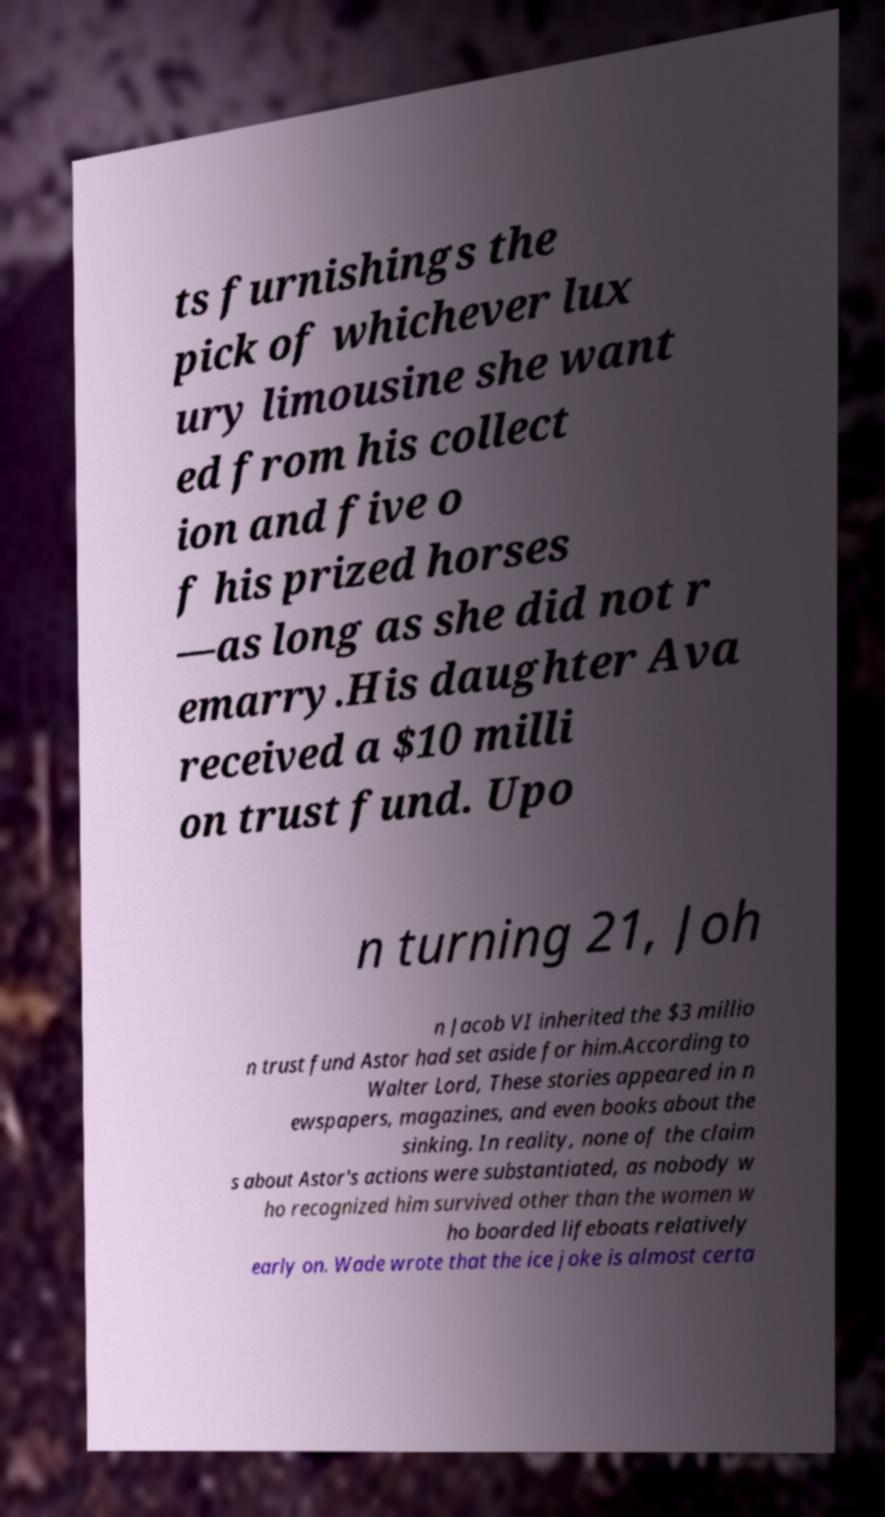Can you accurately transcribe the text from the provided image for me? ts furnishings the pick of whichever lux ury limousine she want ed from his collect ion and five o f his prized horses —as long as she did not r emarry.His daughter Ava received a $10 milli on trust fund. Upo n turning 21, Joh n Jacob VI inherited the $3 millio n trust fund Astor had set aside for him.According to Walter Lord, These stories appeared in n ewspapers, magazines, and even books about the sinking. In reality, none of the claim s about Astor's actions were substantiated, as nobody w ho recognized him survived other than the women w ho boarded lifeboats relatively early on. Wade wrote that the ice joke is almost certa 